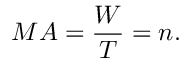<formula> <loc_0><loc_0><loc_500><loc_500>M A = { \frac { W } { T } } = n .</formula> 